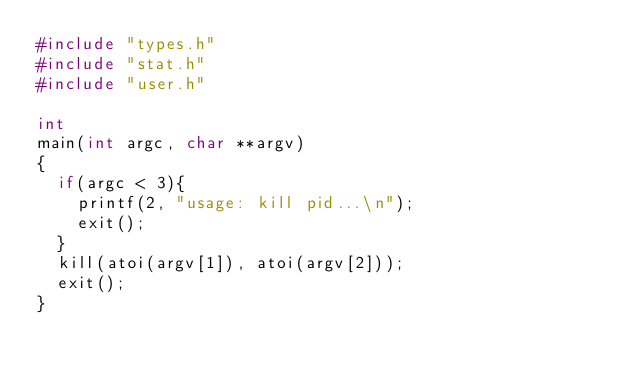<code> <loc_0><loc_0><loc_500><loc_500><_C_>#include "types.h"
#include "stat.h"
#include "user.h"

int
main(int argc, char **argv)
{
  if(argc < 3){
    printf(2, "usage: kill pid...\n");
    exit();
  }
  kill(atoi(argv[1]), atoi(argv[2]));
  exit();
}
</code> 